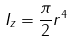Convert formula to latex. <formula><loc_0><loc_0><loc_500><loc_500>I _ { z } = \frac { \pi } { 2 } r ^ { 4 }</formula> 